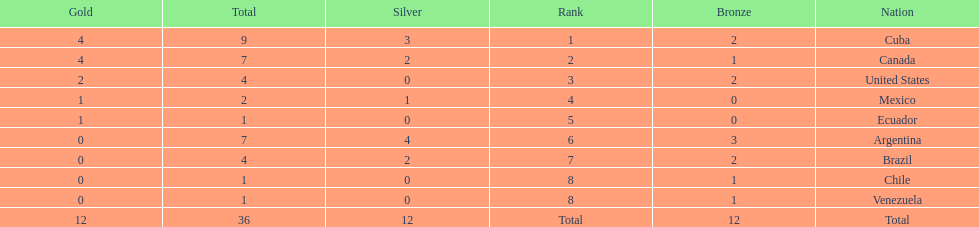Who had more silver medals, cuba or brazil? Cuba. 